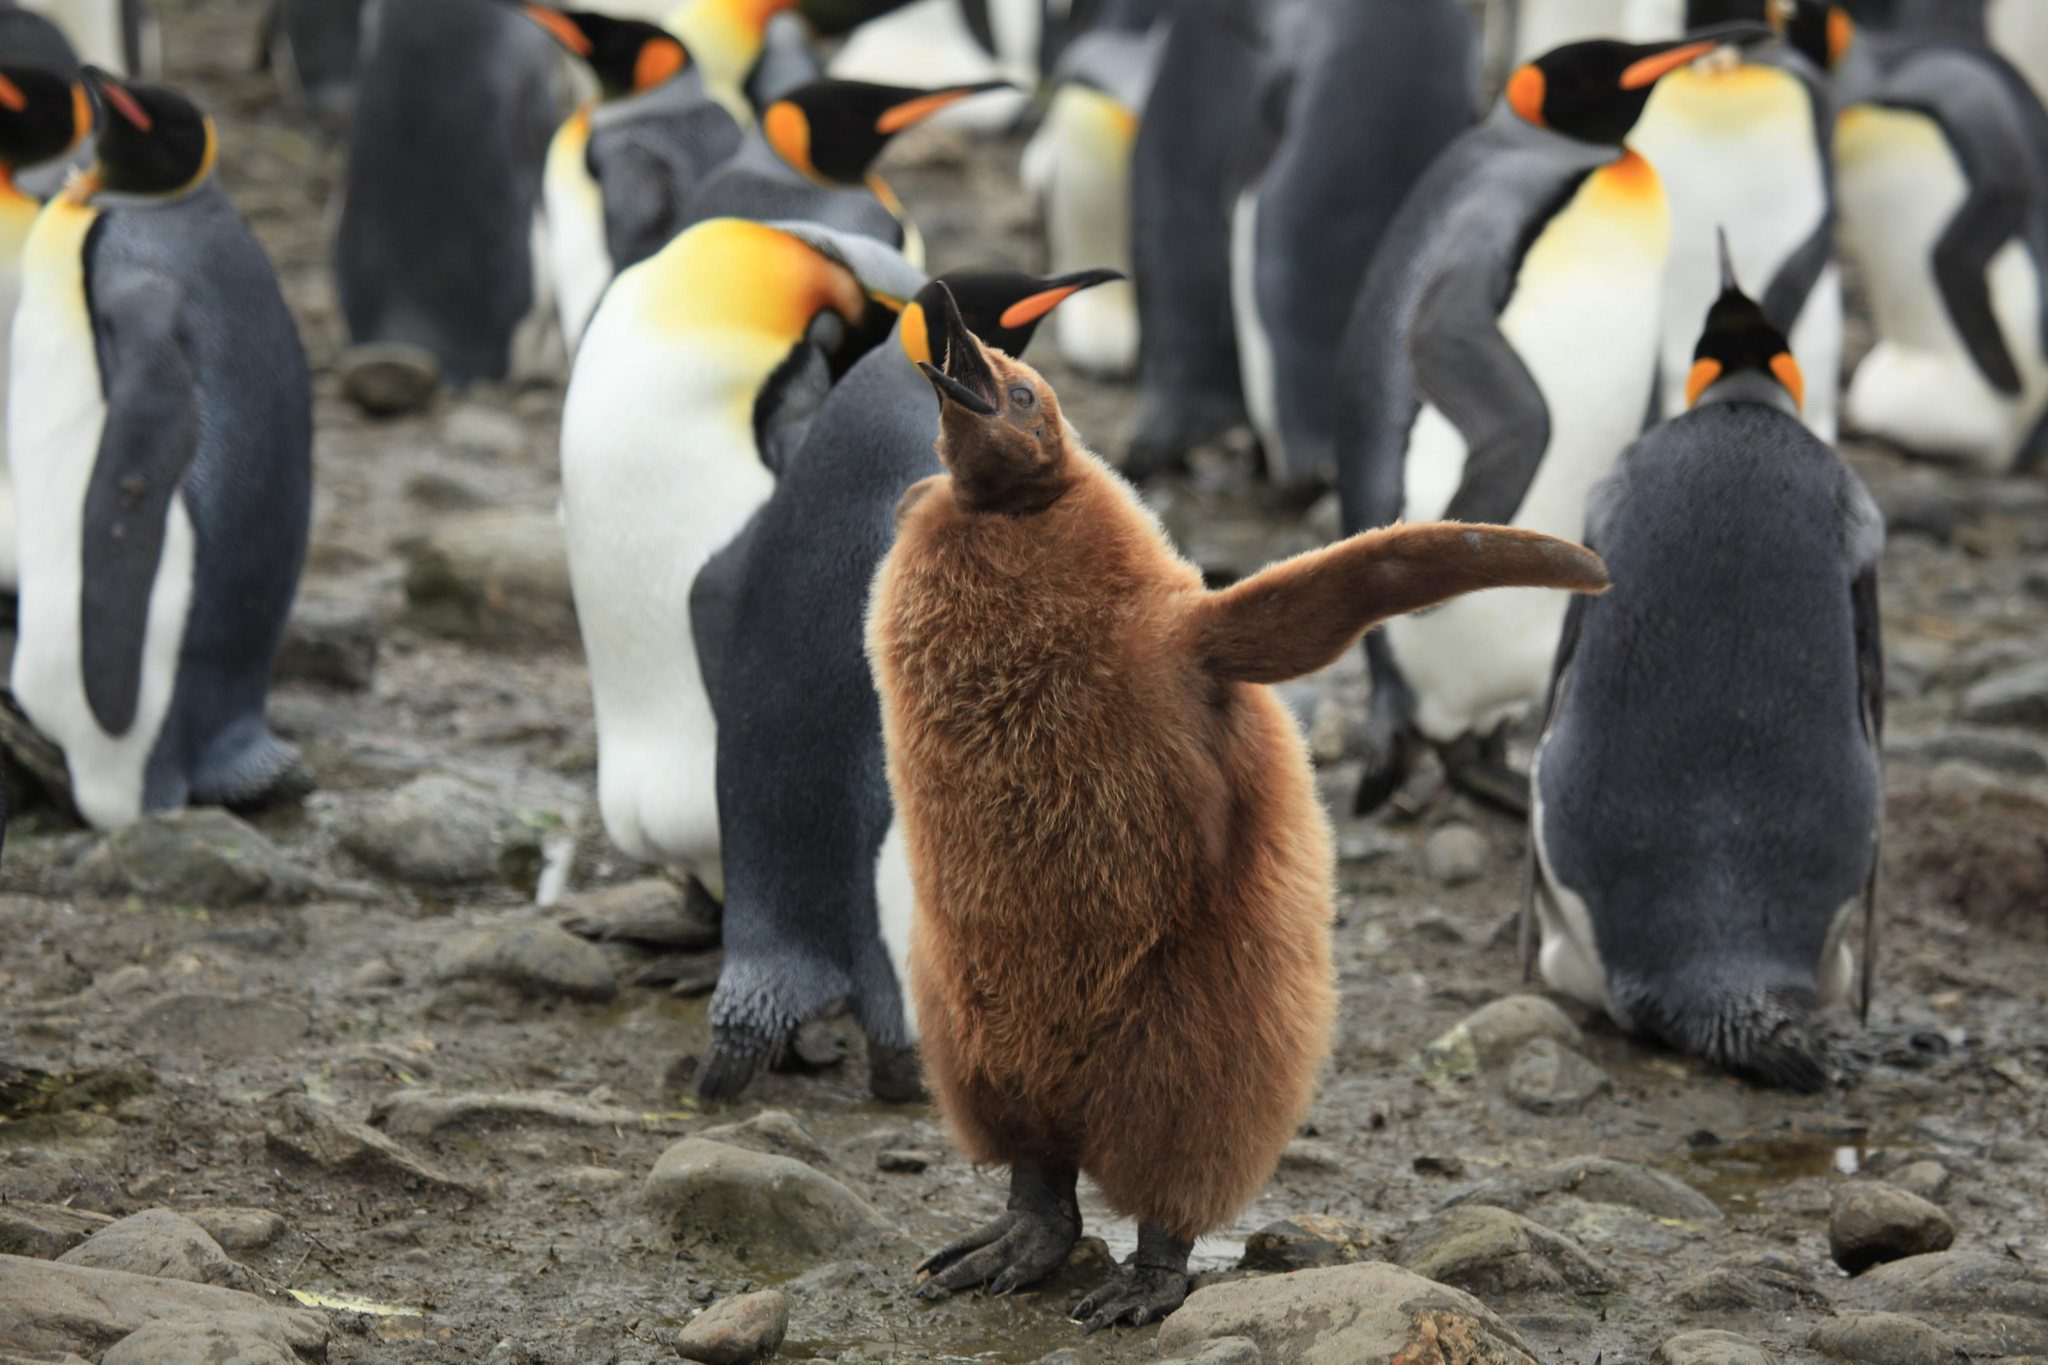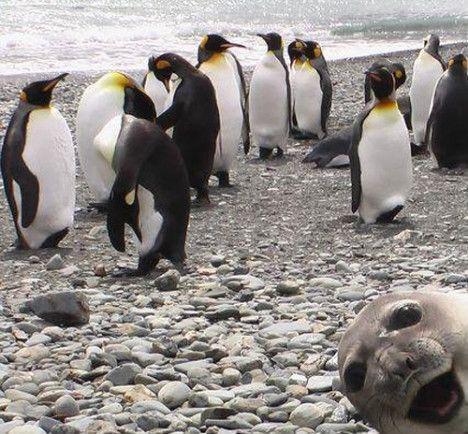The first image is the image on the left, the second image is the image on the right. For the images shown, is this caption "One of the images shows a penguin that is brown and fuzzy standing near a black and white penguin." true? Answer yes or no. Yes. The first image is the image on the left, the second image is the image on the right. Analyze the images presented: Is the assertion "A seal photobombs in the lower right corner of one of the pictures." valid? Answer yes or no. Yes. 